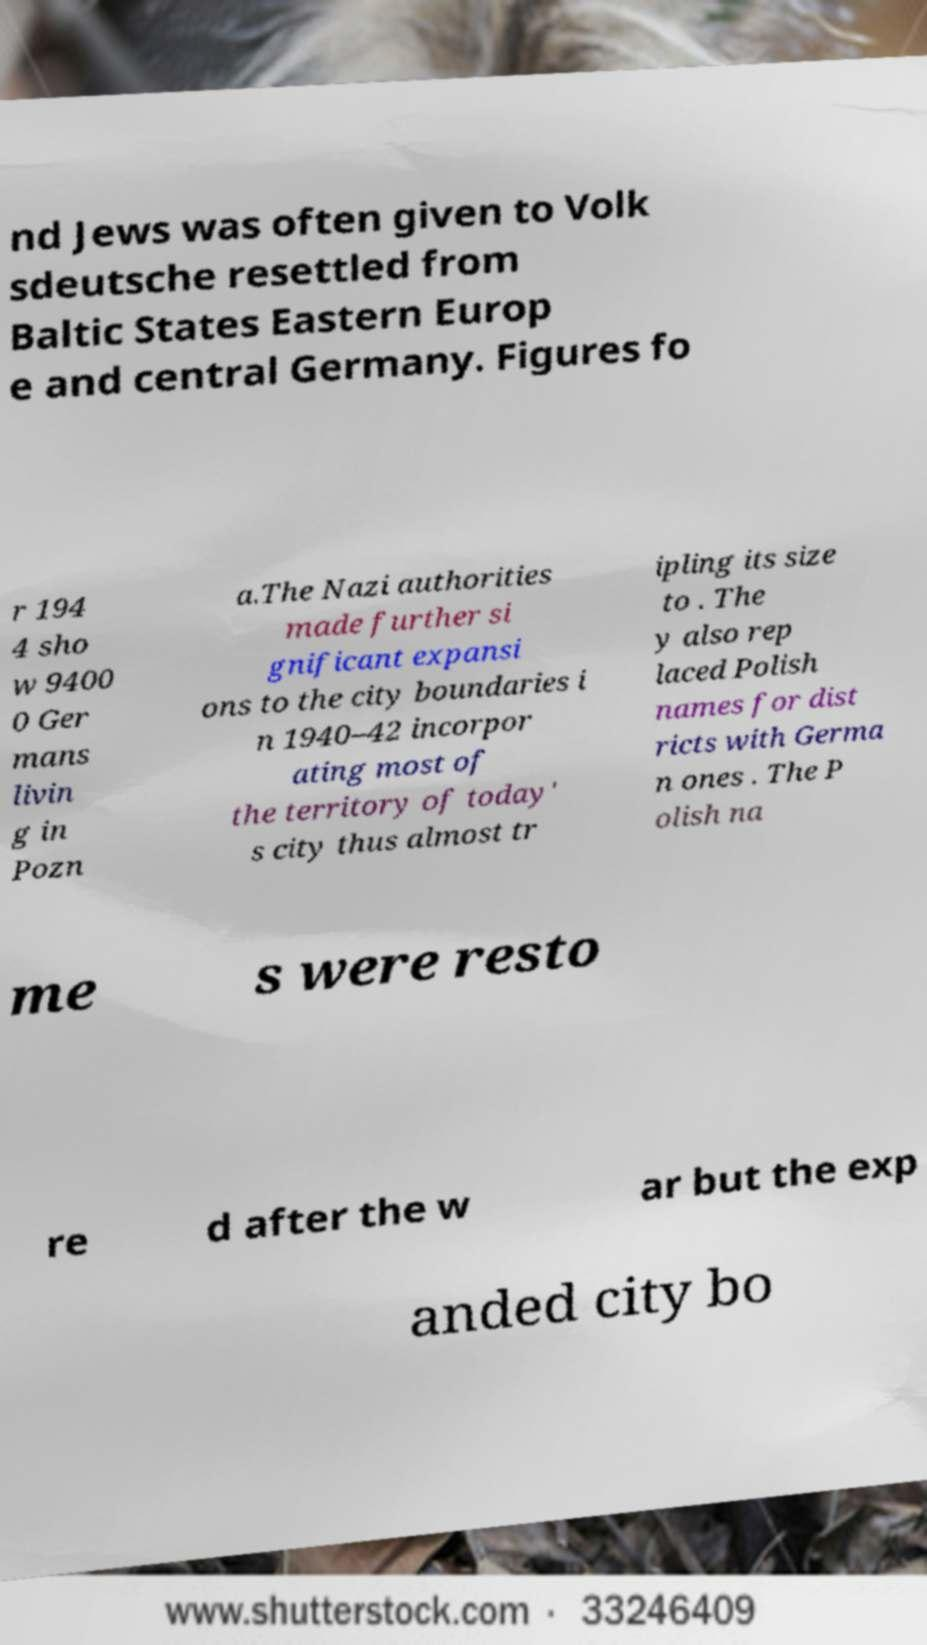Could you extract and type out the text from this image? nd Jews was often given to Volk sdeutsche resettled from Baltic States Eastern Europ e and central Germany. Figures fo r 194 4 sho w 9400 0 Ger mans livin g in Pozn a.The Nazi authorities made further si gnificant expansi ons to the city boundaries i n 1940–42 incorpor ating most of the territory of today' s city thus almost tr ipling its size to . The y also rep laced Polish names for dist ricts with Germa n ones . The P olish na me s were resto re d after the w ar but the exp anded city bo 